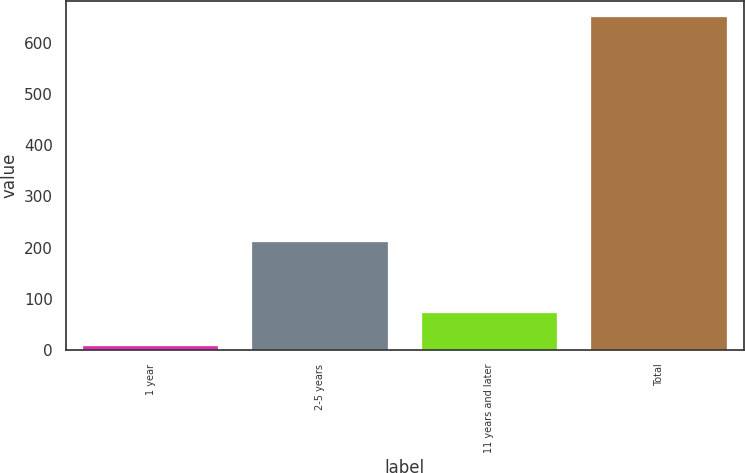<chart> <loc_0><loc_0><loc_500><loc_500><bar_chart><fcel>1 year<fcel>2-5 years<fcel>11 years and later<fcel>Total<nl><fcel>8<fcel>212<fcel>73<fcel>649<nl></chart> 